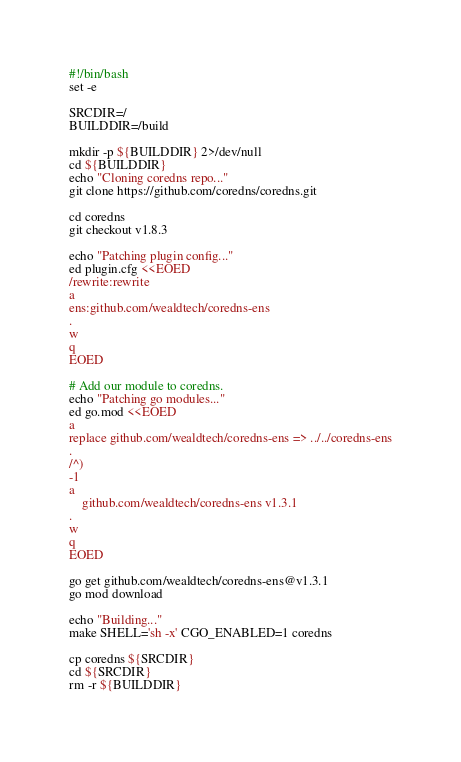Convert code to text. <code><loc_0><loc_0><loc_500><loc_500><_Bash_>#!/bin/bash
set -e

SRCDIR=/
BUILDDIR=/build

mkdir -p ${BUILDDIR} 2>/dev/null
cd ${BUILDDIR}
echo "Cloning coredns repo..."
git clone https://github.com/coredns/coredns.git

cd coredns
git checkout v1.8.3

echo "Patching plugin config..."
ed plugin.cfg <<EOED
/rewrite:rewrite
a
ens:github.com/wealdtech/coredns-ens
.
w
q
EOED

# Add our module to coredns.
echo "Patching go modules..."
ed go.mod <<EOED
a
replace github.com/wealdtech/coredns-ens => ../../coredns-ens
.
/^)
-1
a
	github.com/wealdtech/coredns-ens v1.3.1
.
w
q
EOED

go get github.com/wealdtech/coredns-ens@v1.3.1
go mod download

echo "Building..."
make SHELL='sh -x' CGO_ENABLED=1 coredns

cp coredns ${SRCDIR}
cd ${SRCDIR}
rm -r ${BUILDDIR}
</code> 